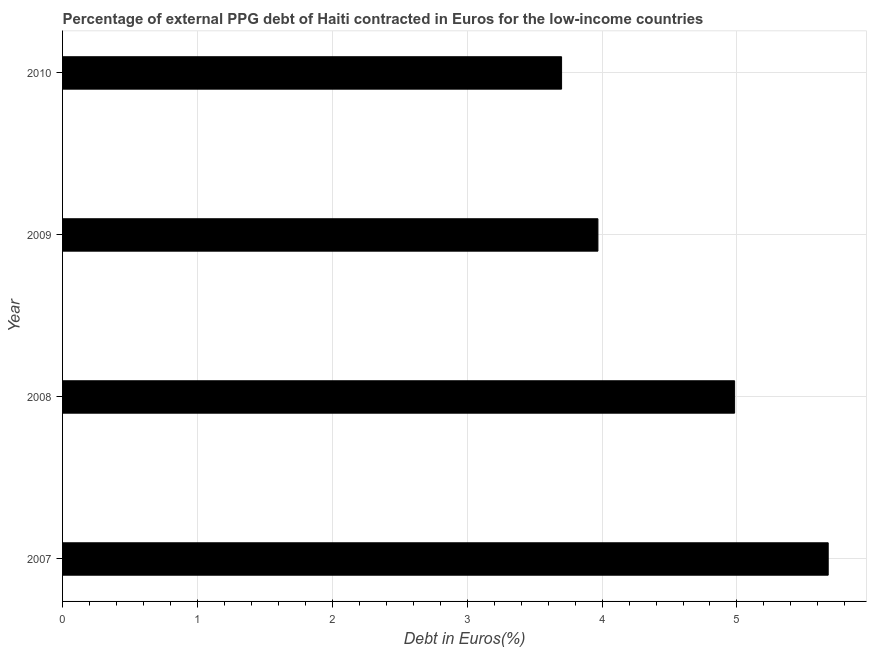Does the graph contain any zero values?
Your answer should be very brief. No. What is the title of the graph?
Keep it short and to the point. Percentage of external PPG debt of Haiti contracted in Euros for the low-income countries. What is the label or title of the X-axis?
Provide a short and direct response. Debt in Euros(%). What is the label or title of the Y-axis?
Your response must be concise. Year. What is the currency composition of ppg debt in 2007?
Your answer should be very brief. 5.68. Across all years, what is the maximum currency composition of ppg debt?
Your answer should be compact. 5.68. Across all years, what is the minimum currency composition of ppg debt?
Keep it short and to the point. 3.7. In which year was the currency composition of ppg debt minimum?
Your answer should be very brief. 2010. What is the sum of the currency composition of ppg debt?
Offer a terse response. 18.33. What is the difference between the currency composition of ppg debt in 2007 and 2010?
Ensure brevity in your answer.  1.98. What is the average currency composition of ppg debt per year?
Offer a terse response. 4.58. What is the median currency composition of ppg debt?
Provide a succinct answer. 4.48. Do a majority of the years between 2008 and 2009 (inclusive) have currency composition of ppg debt greater than 3 %?
Provide a short and direct response. Yes. What is the ratio of the currency composition of ppg debt in 2009 to that in 2010?
Your response must be concise. 1.07. Is the difference between the currency composition of ppg debt in 2008 and 2010 greater than the difference between any two years?
Your response must be concise. No. What is the difference between the highest and the second highest currency composition of ppg debt?
Your response must be concise. 0.69. Is the sum of the currency composition of ppg debt in 2007 and 2010 greater than the maximum currency composition of ppg debt across all years?
Ensure brevity in your answer.  Yes. What is the difference between the highest and the lowest currency composition of ppg debt?
Provide a succinct answer. 1.98. How many bars are there?
Ensure brevity in your answer.  4. How many years are there in the graph?
Your answer should be very brief. 4. What is the Debt in Euros(%) of 2007?
Offer a terse response. 5.68. What is the Debt in Euros(%) in 2008?
Provide a short and direct response. 4.98. What is the Debt in Euros(%) in 2009?
Your response must be concise. 3.97. What is the Debt in Euros(%) in 2010?
Your response must be concise. 3.7. What is the difference between the Debt in Euros(%) in 2007 and 2008?
Offer a very short reply. 0.69. What is the difference between the Debt in Euros(%) in 2007 and 2009?
Provide a succinct answer. 1.71. What is the difference between the Debt in Euros(%) in 2007 and 2010?
Your answer should be very brief. 1.98. What is the difference between the Debt in Euros(%) in 2008 and 2009?
Give a very brief answer. 1.01. What is the difference between the Debt in Euros(%) in 2008 and 2010?
Offer a terse response. 1.28. What is the difference between the Debt in Euros(%) in 2009 and 2010?
Provide a succinct answer. 0.27. What is the ratio of the Debt in Euros(%) in 2007 to that in 2008?
Keep it short and to the point. 1.14. What is the ratio of the Debt in Euros(%) in 2007 to that in 2009?
Your answer should be compact. 1.43. What is the ratio of the Debt in Euros(%) in 2007 to that in 2010?
Your answer should be very brief. 1.53. What is the ratio of the Debt in Euros(%) in 2008 to that in 2009?
Make the answer very short. 1.25. What is the ratio of the Debt in Euros(%) in 2008 to that in 2010?
Ensure brevity in your answer.  1.35. What is the ratio of the Debt in Euros(%) in 2009 to that in 2010?
Give a very brief answer. 1.07. 